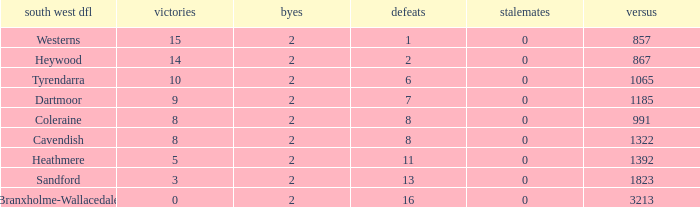How many wins have 16 losses and an Against smaller than 3213? None. 